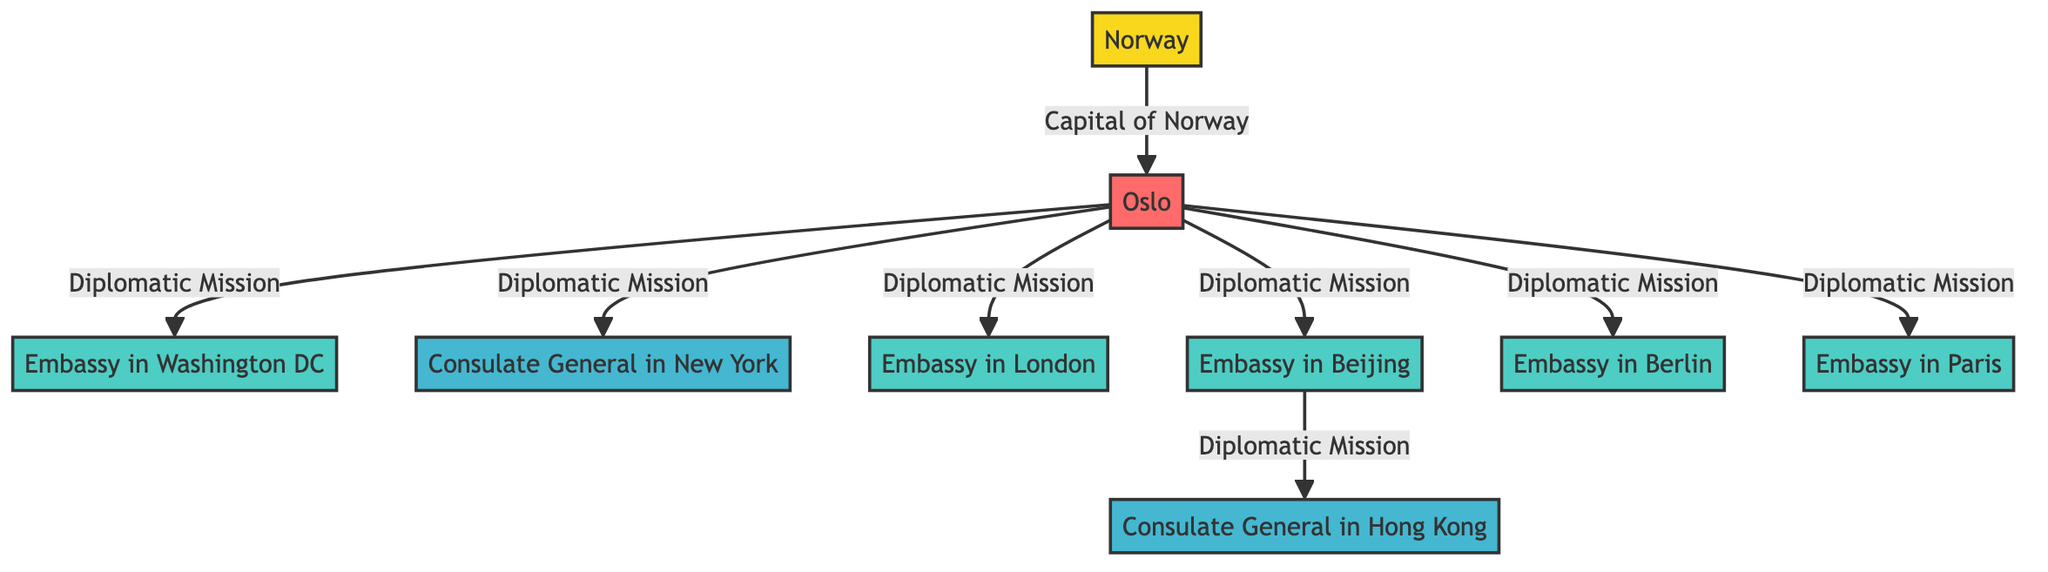What is the capital of Norway? According to the diagram, Norway is linked to Oslo, which is labeled as the capital. Therefore, the capital of Norway is Oslo.
Answer: Oslo How many embassies does Norway have? The diagram shows Embassies in Washington, London, Beijing, Berlin, and Paris. Counting these nodes gives a total of five embassies.
Answer: 5 What is the relationship between Oslo and Washington? The diagram indicates a direct link from Oslo to Washington, labeled as "Diplomatic Mission," illustrating that Washington is one of Norway's diplomatic missions.
Answer: Diplomatic Mission Which city has a Consulate General from Norway? The diagram highlights the Consulate General in New York and the Consulate General in Hong Kong as linked to Oslo, indicating cities where Norway has consulates.
Answer: New York Name one city where Norway has an embassy. The diagram lists multiple destinations as embassies, such as Washington, London, and Berlin. Any of these cities would be a correct answer, but one notable example is Washington.
Answer: Washington How many diplomatic missions are connected directly to Oslo? The diagram shows direct links from Oslo to its various diplomatic missions: Washington, New York, London, Beijing, Berlin, and Paris. Counting these connections gives a total of six.
Answer: 6 What is the relationship between Beijing and Hong Kong? The diagram depicts a link from Beijing to Hong Kong, indicating that Hong Kong is a consulate under the diplomatic mission of Beijing.
Answer: Diplomatic Mission Which country is represented in the diagram? The diagram clearly states "Norway" as the main subject, indicating that Norway's diplomatic missions are being illustrated.
Answer: Norway Which city is the most eastern embassy listed? The diagram shows embassies in various locations, and comparing their geographical positions, Beijing is the most eastern embassy listed.
Answer: Beijing 